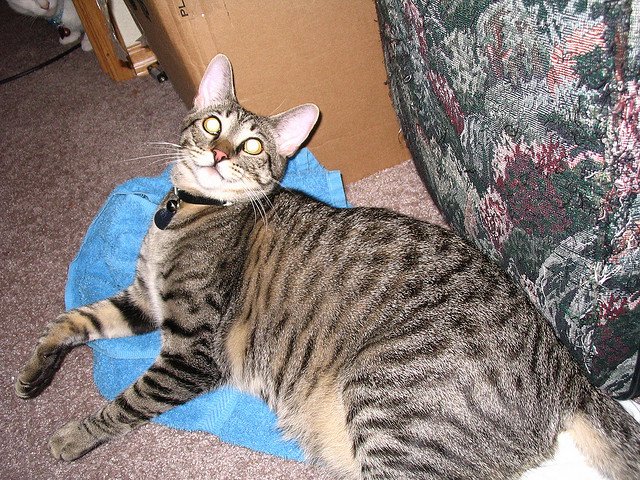Identify the text contained in this image. PL 